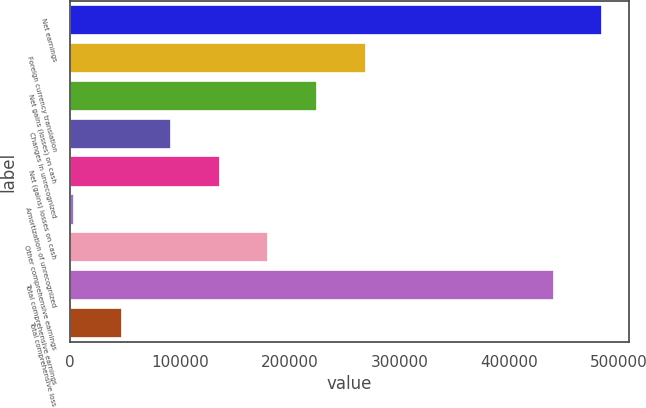Convert chart to OTSL. <chart><loc_0><loc_0><loc_500><loc_500><bar_chart><fcel>Net earnings<fcel>Foreign currency translation<fcel>Net gains (losses) on cash<fcel>Changes in unrecognized<fcel>Net (gains) losses on cash<fcel>Amortization of unrecognized<fcel>Other comprehensive earnings<fcel>Total comprehensive earnings<fcel>Total comprehensive loss<nl><fcel>485046<fcel>269431<fcel>225070<fcel>91989.6<fcel>136350<fcel>3269<fcel>180710<fcel>440685<fcel>47629.3<nl></chart> 